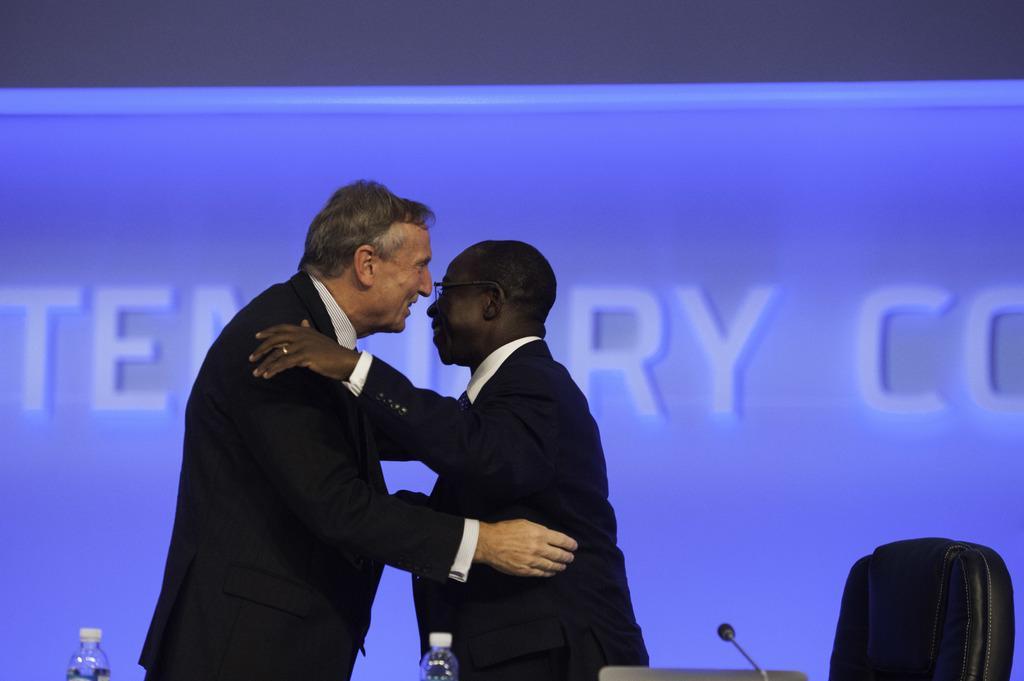How would you summarize this image in a sentence or two? Here I can see two men wearing black color suits, smiling and hugging each other. At the bottom there are two bottles and a mike. On the right side there is a chair. In the background there is a blue color board on which there is some text. 